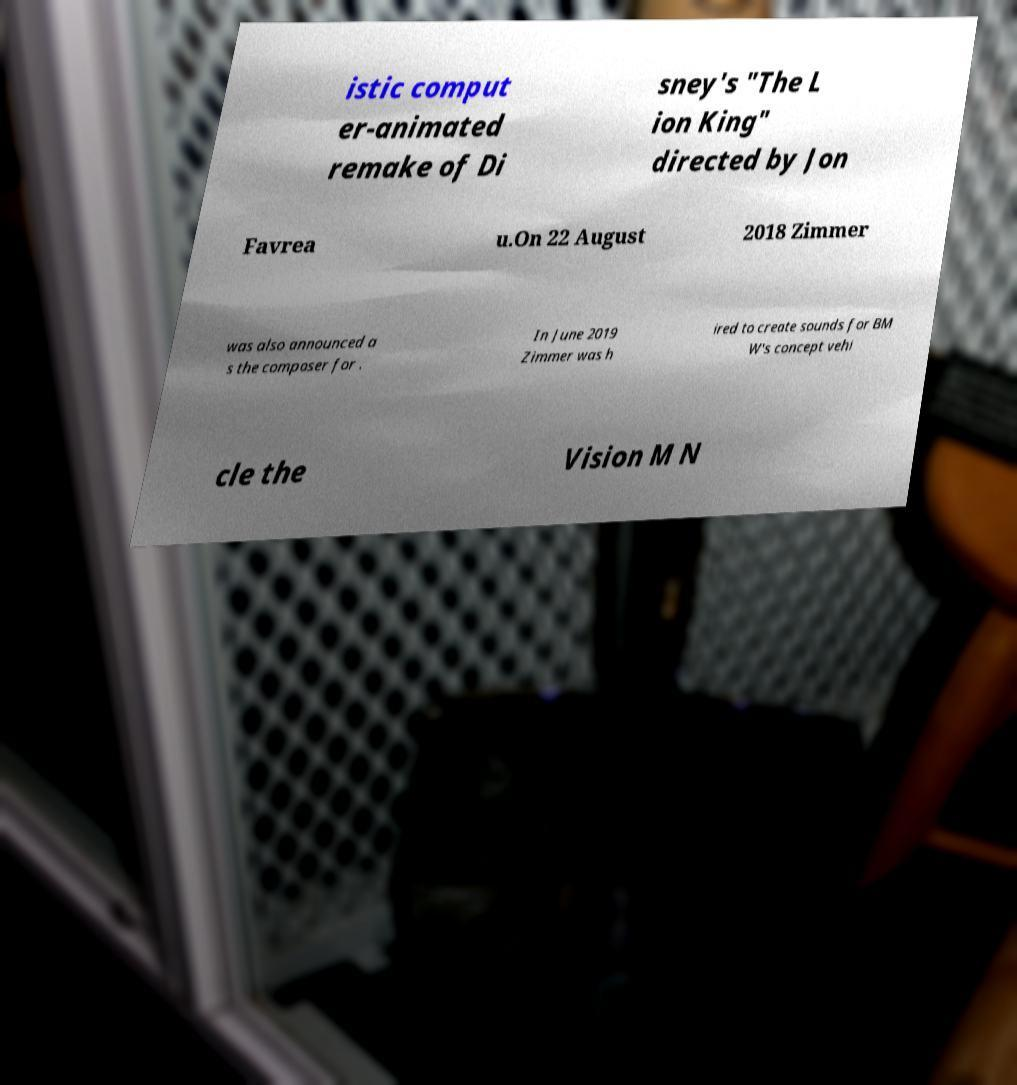Can you read and provide the text displayed in the image?This photo seems to have some interesting text. Can you extract and type it out for me? istic comput er-animated remake of Di sney's "The L ion King" directed by Jon Favrea u.On 22 August 2018 Zimmer was also announced a s the composer for . In June 2019 Zimmer was h ired to create sounds for BM W's concept vehi cle the Vision M N 